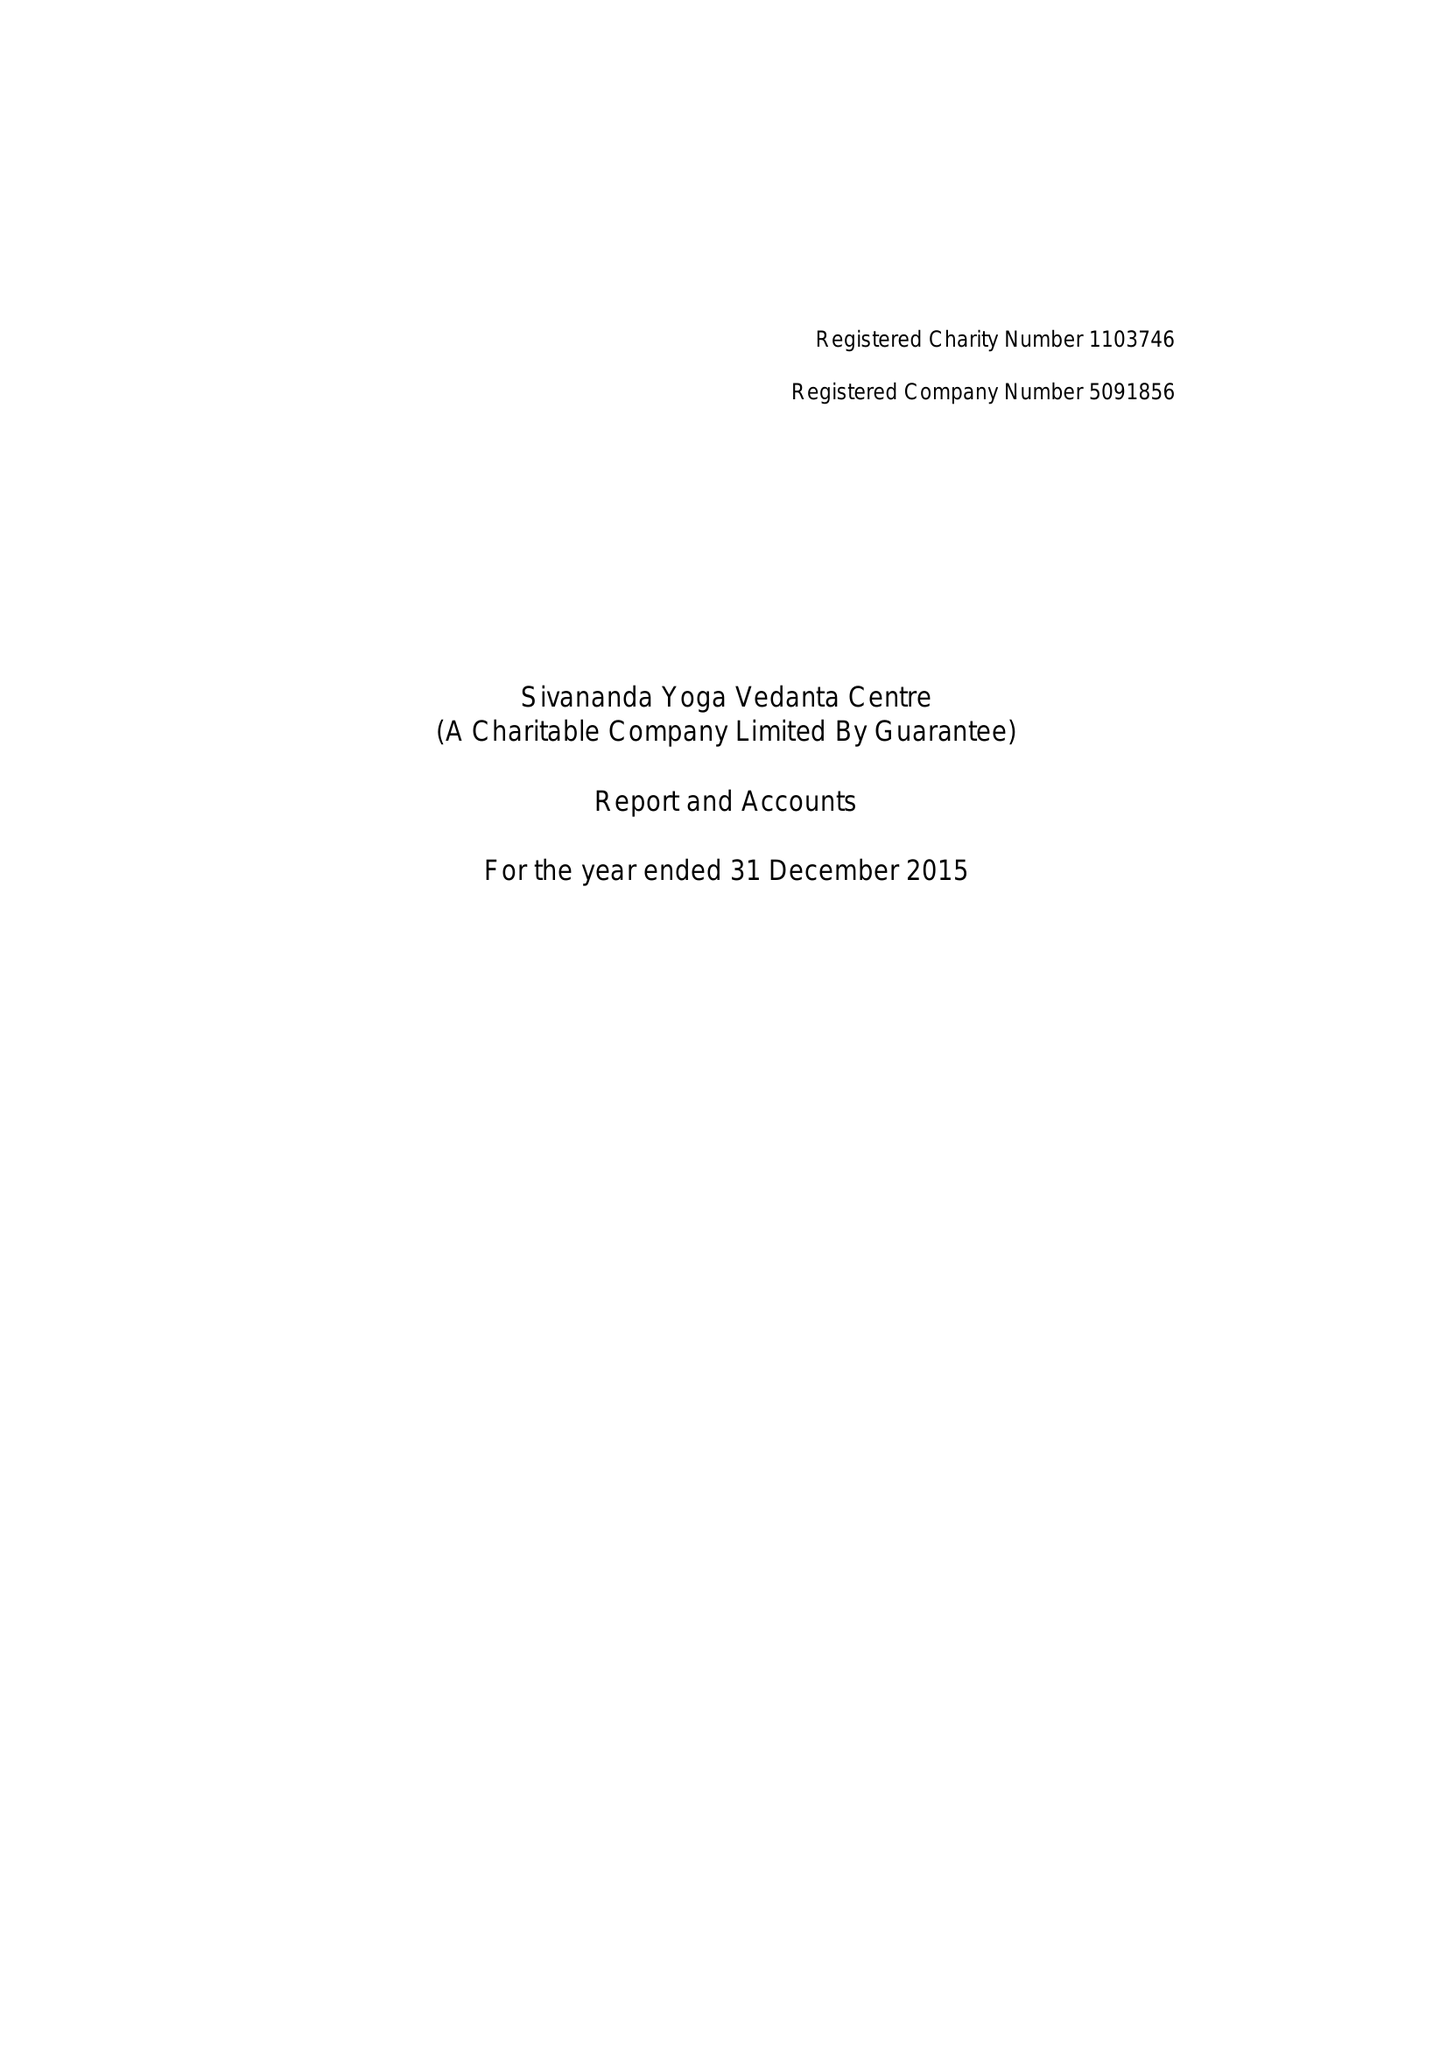What is the value for the address__street_line?
Answer the question using a single word or phrase. 51 FELSHAM ROAD 